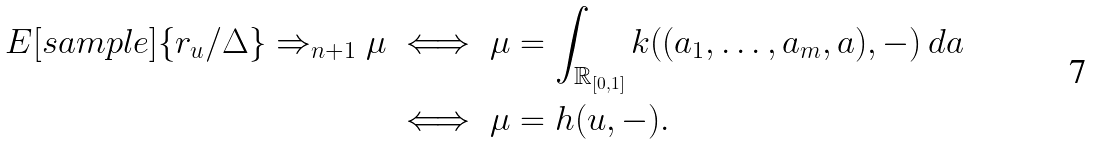Convert formula to latex. <formula><loc_0><loc_0><loc_500><loc_500>E [ s a m p l e ] \{ r _ { u } / \Delta \} \Rightarrow _ { n + 1 } \mu & \iff \mu = \int _ { \mathbb { R } _ { [ 0 , 1 ] } } k ( ( a _ { 1 } , \dots , a _ { m } , a ) , - ) \, d a \\ & \iff \mu = h ( u , - ) .</formula> 